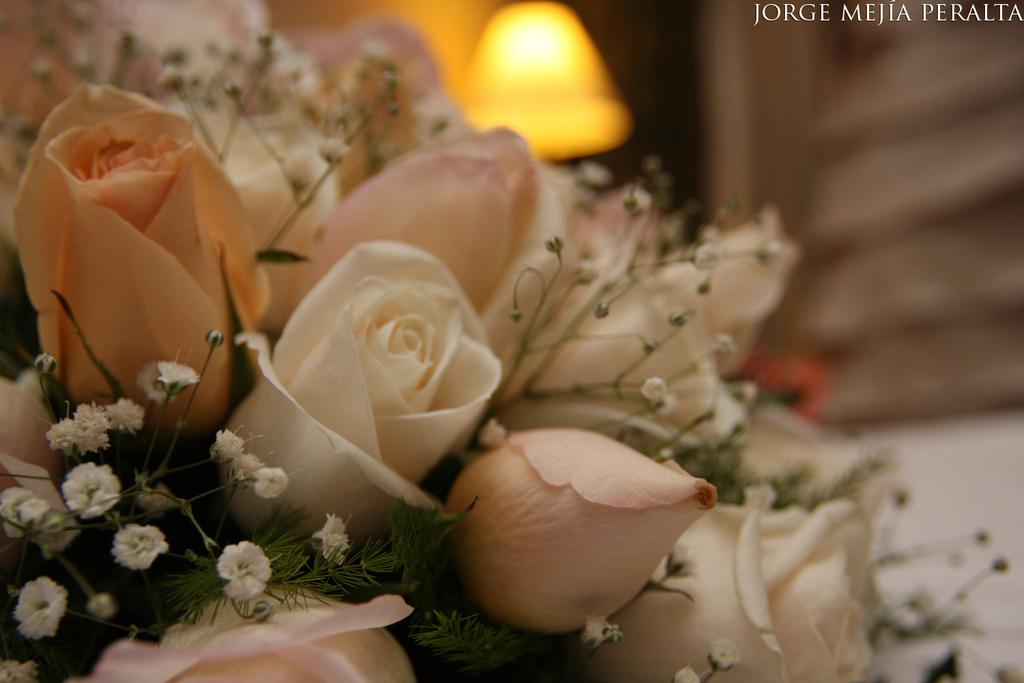What type of vegetation is on the left side of the image? There are flowers on the left side of the image. How would you describe the background of the image? The background of the image is blurred. What object provides light in the image? There is a lamp in the image. Where is the name located in the image? The name is in the top right corner of the image. What type of locket is hanging from the lamp in the image? There is no locket hanging from the lamp in the image; only a lamp is present. What kind of watch is visible on the flowers in the image? There is no watch visible on the flowers in the image; only flowers are present. 